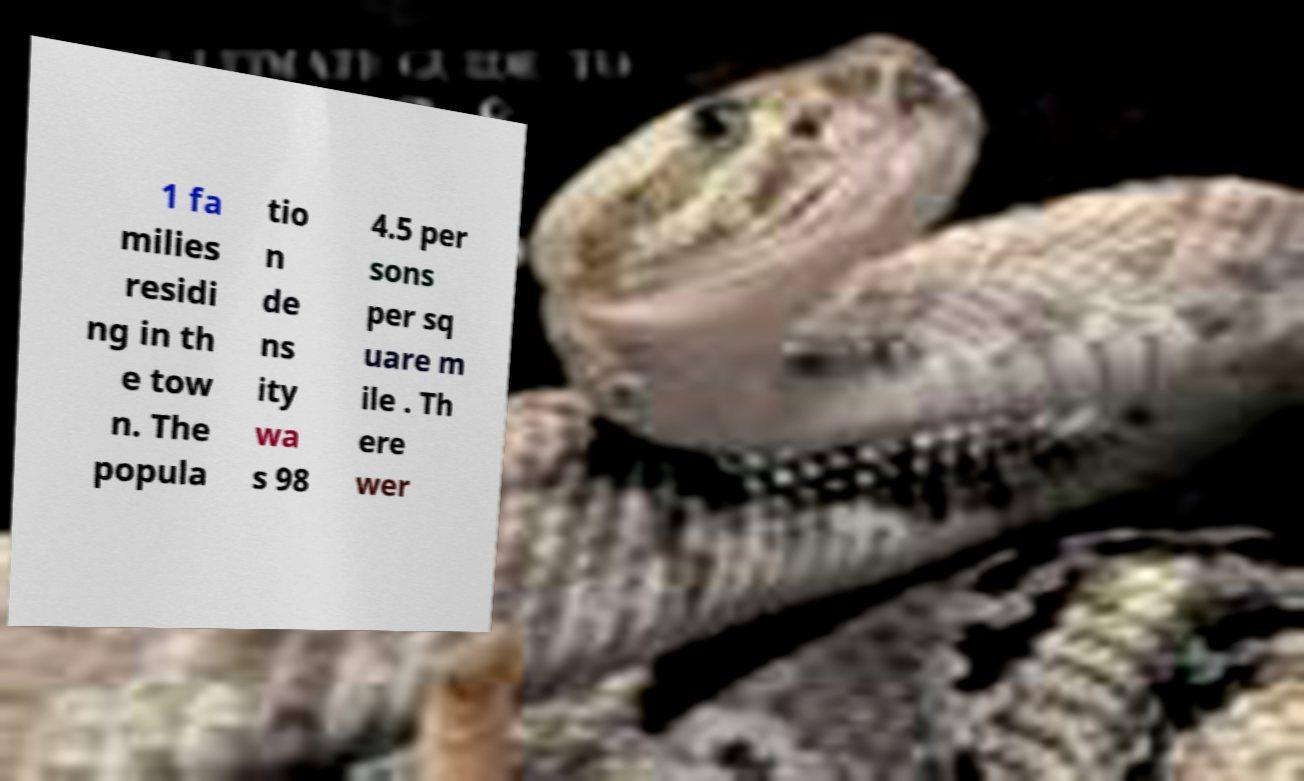Please read and relay the text visible in this image. What does it say? 1 fa milies residi ng in th e tow n. The popula tio n de ns ity wa s 98 4.5 per sons per sq uare m ile . Th ere wer 